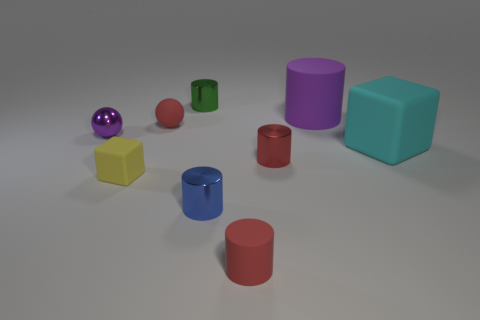Subtract all purple cylinders. How many cylinders are left? 4 Subtract all small red metal cylinders. How many cylinders are left? 4 Subtract all blue cylinders. Subtract all gray cubes. How many cylinders are left? 4 Add 1 large red cylinders. How many objects exist? 10 Subtract all balls. How many objects are left? 7 Subtract 0 purple cubes. How many objects are left? 9 Subtract all brown cylinders. Subtract all tiny blue cylinders. How many objects are left? 8 Add 6 red metal cylinders. How many red metal cylinders are left? 7 Add 6 small brown matte cylinders. How many small brown matte cylinders exist? 6 